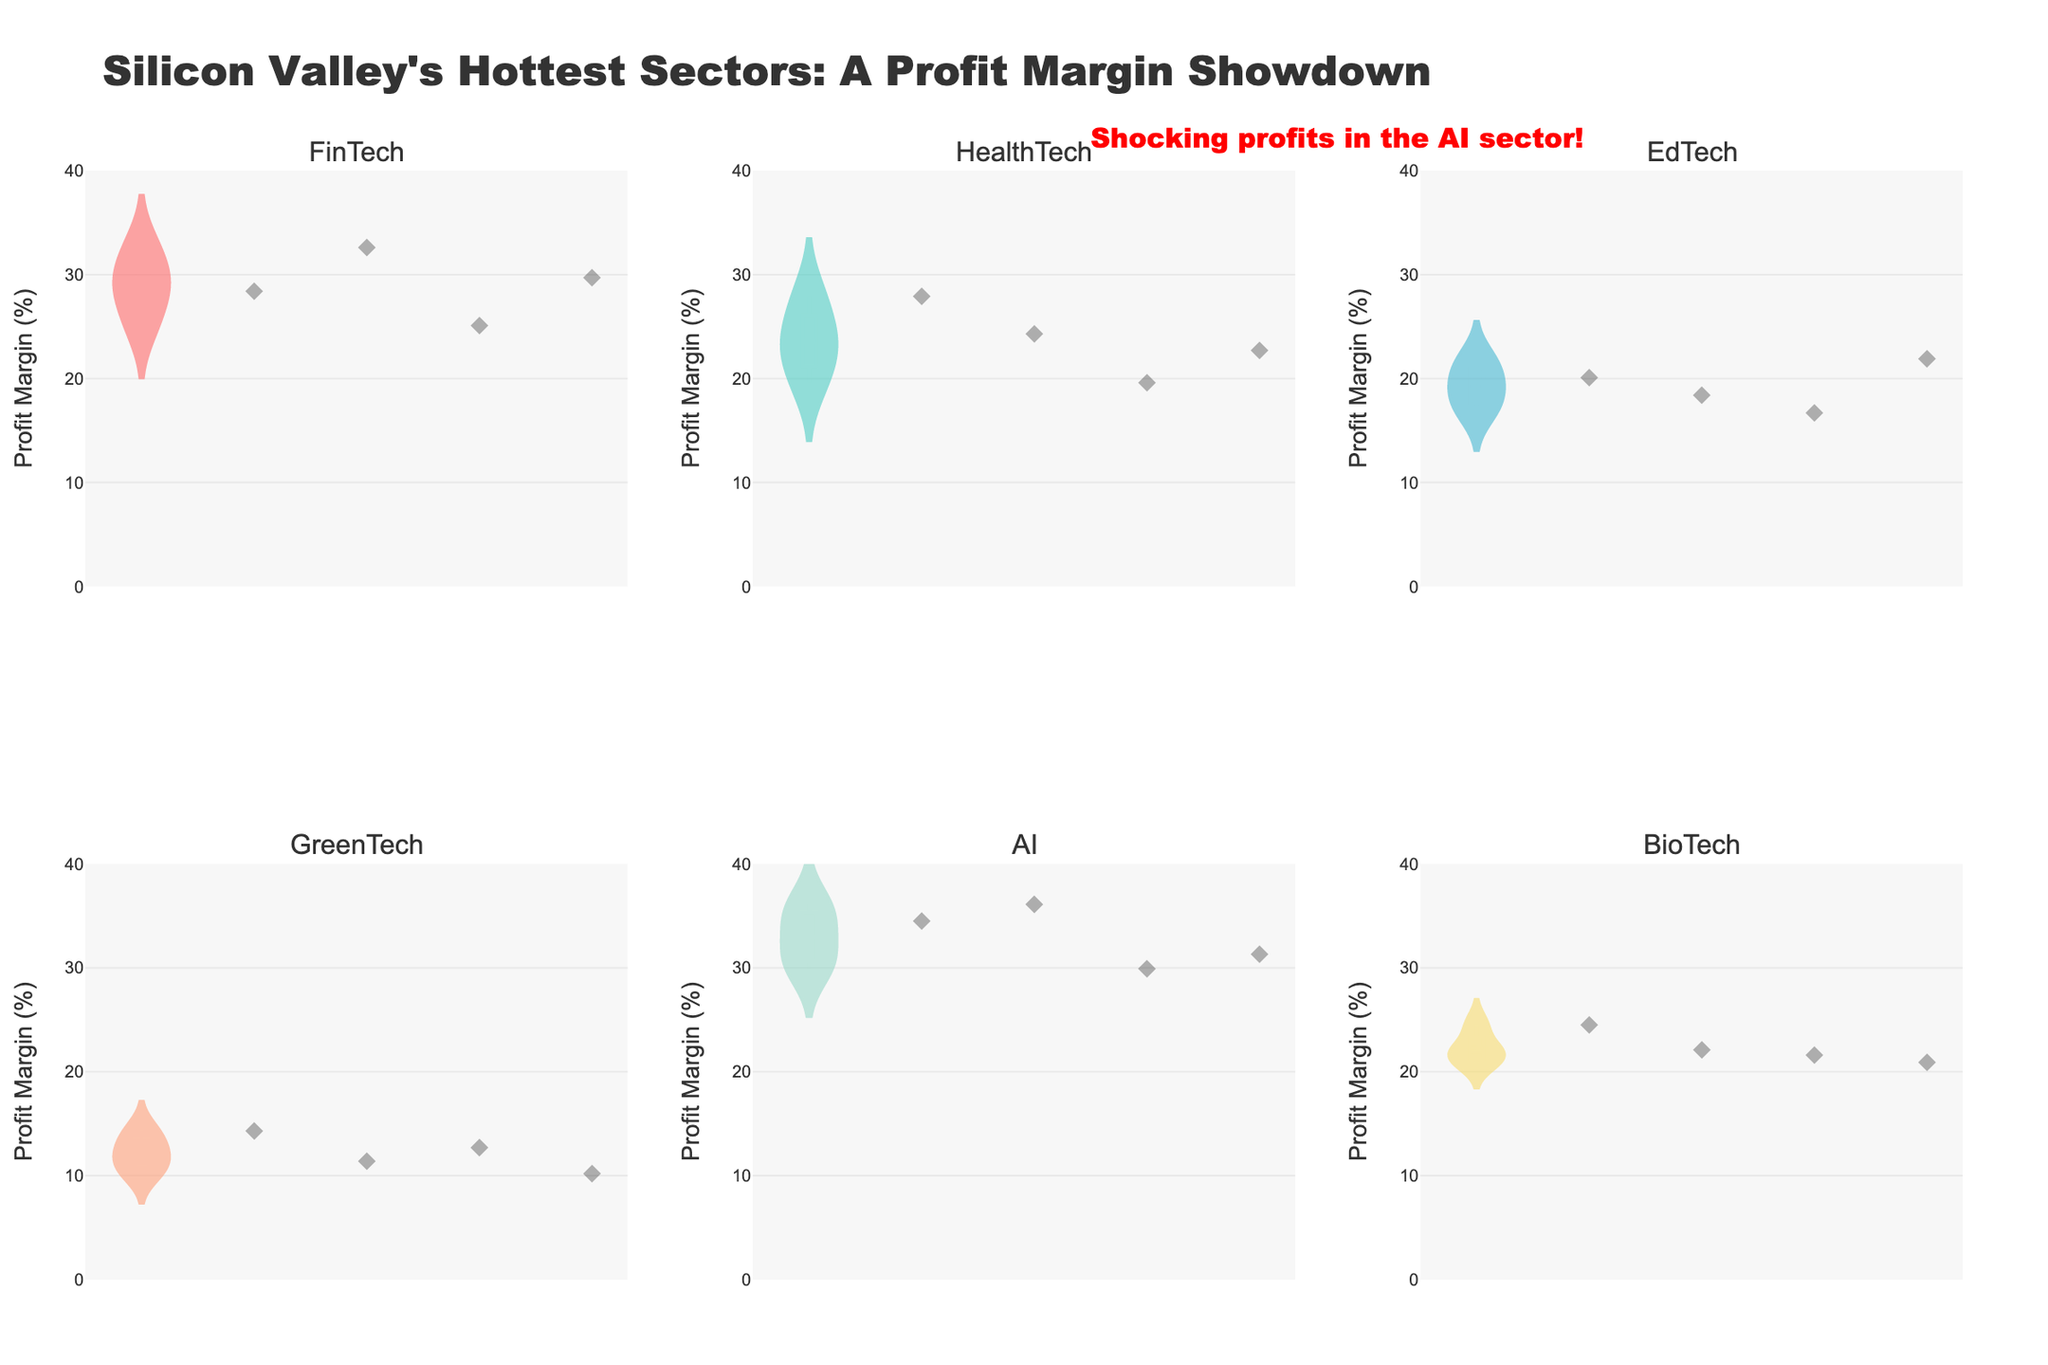What is the title of the plot? The title is located at the top of the plot in a larger font size, which reads "Silicon Valley's Hottest Sectors: A Profit Margin Showdown".
Answer: Silicon Valley's Hottest Sectors: A Profit Margin Showdown Which sector shows the highest profit margins? By observing the plot, the AI sector has the highest and most prominent profit margins, indicated by the highest position of the violin plot.
Answer: AI How does the median profit margin compare between the FinTech and GreenTech sectors? The median profit margin is marked by a horizontal line inside each violin plot. The FinTech sector's median line is significantly higher than the GreenTech sector's median line.
Answer: FinTech's median is higher Which sector has the widest range of profit margins? The width of the violin plot represents the distribution spread. The AI sector has the widest plot, indicating a broad range of profit margins.
Answer: AI How many sectors are compared in the plot? By counting the subplot titles, which are displayed at the top of each individual violin plot, we see that there are a total of 6 sectors being compared.
Answer: 6 Which sector has the smallest profit margin spread? The GreenTech sector has the narrowest violin plot, indicating a smaller spread of profit margins among its companies.
Answer: GreenTech Are there more companies with profit margins above 30% in the AI sector compared to the FinTech sector? Looking at the jittered points within the AI and FinTech violins, the AI sector shows more data points above the 30% mark compared to FinTech.
Answer: Yes What is the approximate profit margin for DeepMind in the AI sector? The exact profit margin can be identified from the individual jittered points in the AI violin plot. DeepMind's point is one of the higher ones in this sector plot.
Answer: Approximately 36.1% Which sector annotation suggests shocking profits? The annotation above the plot explicitly states "Shocking profits in the AI sector!", suggesting that the AI sector has notably high profit margins.
Answer: AI sector What sectors have their median profit margins below 25%? Checking the horizontal lines inside the violin plots, GreenTech, EdTech, and BioTech have median profit margins below 25%.
Answer: GreenTech, EdTech, BioTech 